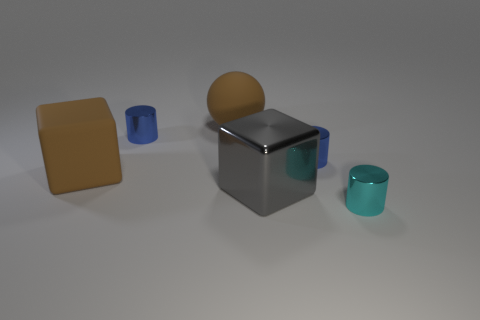Add 1 big matte objects. How many objects exist? 7 Subtract all spheres. How many objects are left? 5 Subtract all large gray objects. Subtract all small yellow matte balls. How many objects are left? 5 Add 4 small blue cylinders. How many small blue cylinders are left? 6 Add 2 large cyan balls. How many large cyan balls exist? 2 Subtract 0 green spheres. How many objects are left? 6 